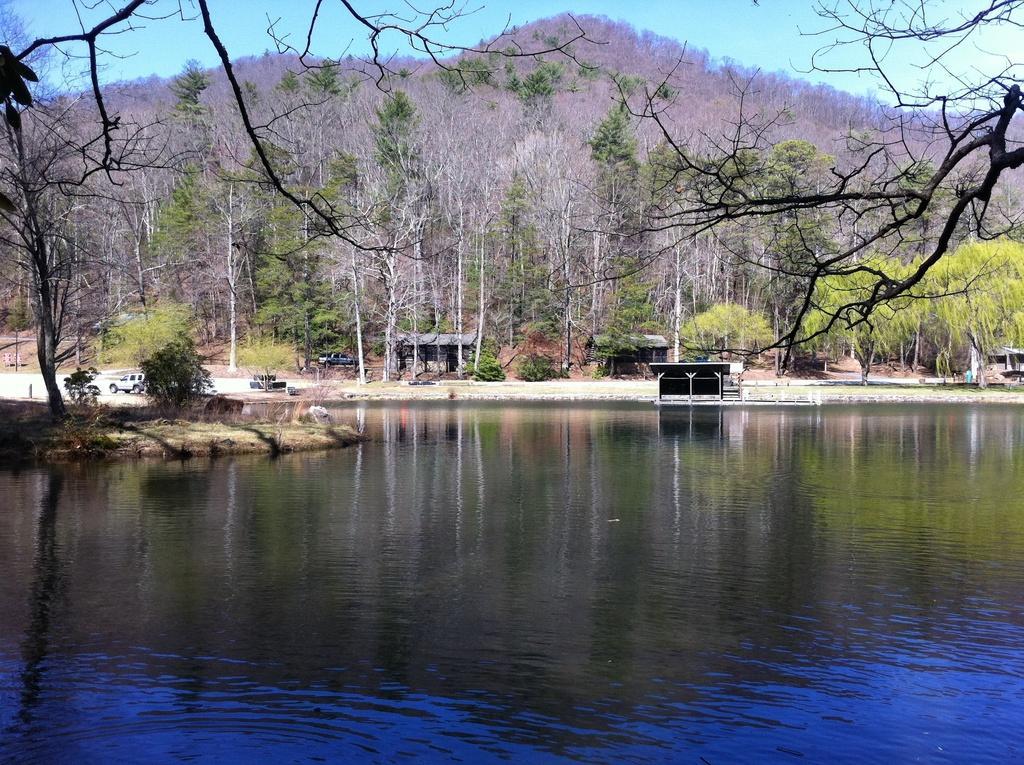Can you describe this image briefly? In the picture we can see water and far away from it, we can see some grass surface on it, we can see a small shed with pillars and behind it we can see trees and hills with trees on it and a sky. 